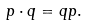<formula> <loc_0><loc_0><loc_500><loc_500>p \cdot q = q p .</formula> 